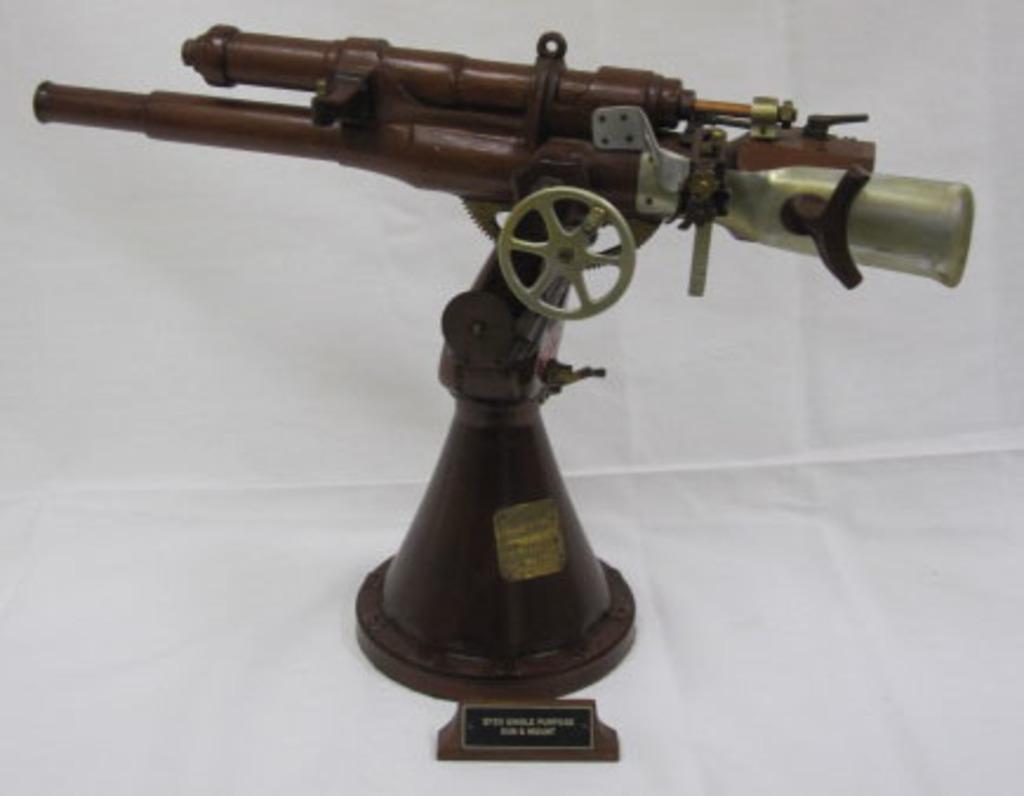Can you describe this image briefly? In this picture we can observe a model of a weapon fixed to the stand. This weapon is in brown color. This weapon is placed on the white color surface. 